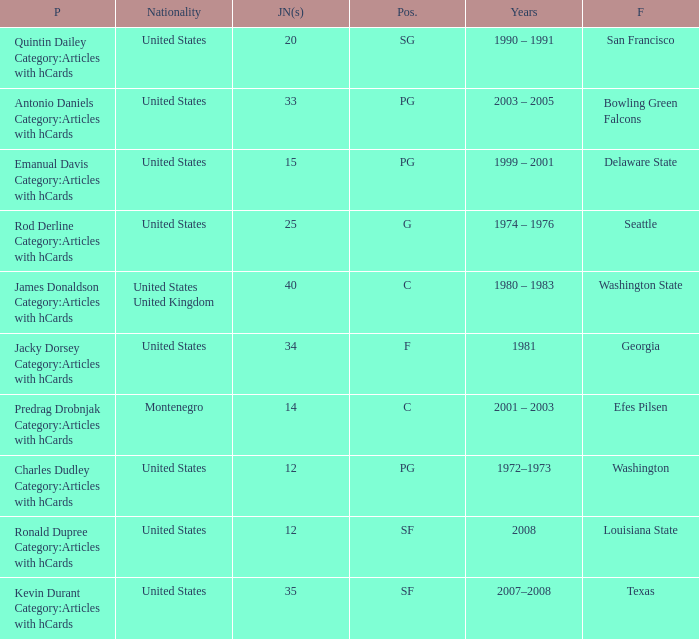What college was the player with the jersey number of 34 from? Georgia. Parse the full table. {'header': ['P', 'Nationality', 'JN(s)', 'Pos.', 'Years', 'F'], 'rows': [['Quintin Dailey Category:Articles with hCards', 'United States', '20', 'SG', '1990 – 1991', 'San Francisco'], ['Antonio Daniels Category:Articles with hCards', 'United States', '33', 'PG', '2003 – 2005', 'Bowling Green Falcons'], ['Emanual Davis Category:Articles with hCards', 'United States', '15', 'PG', '1999 – 2001', 'Delaware State'], ['Rod Derline Category:Articles with hCards', 'United States', '25', 'G', '1974 – 1976', 'Seattle'], ['James Donaldson Category:Articles with hCards', 'United States United Kingdom', '40', 'C', '1980 – 1983', 'Washington State'], ['Jacky Dorsey Category:Articles with hCards', 'United States', '34', 'F', '1981', 'Georgia'], ['Predrag Drobnjak Category:Articles with hCards', 'Montenegro', '14', 'C', '2001 – 2003', 'Efes Pilsen'], ['Charles Dudley Category:Articles with hCards', 'United States', '12', 'PG', '1972–1973', 'Washington'], ['Ronald Dupree Category:Articles with hCards', 'United States', '12', 'SF', '2008', 'Louisiana State'], ['Kevin Durant Category:Articles with hCards', 'United States', '35', 'SF', '2007–2008', 'Texas']]} 